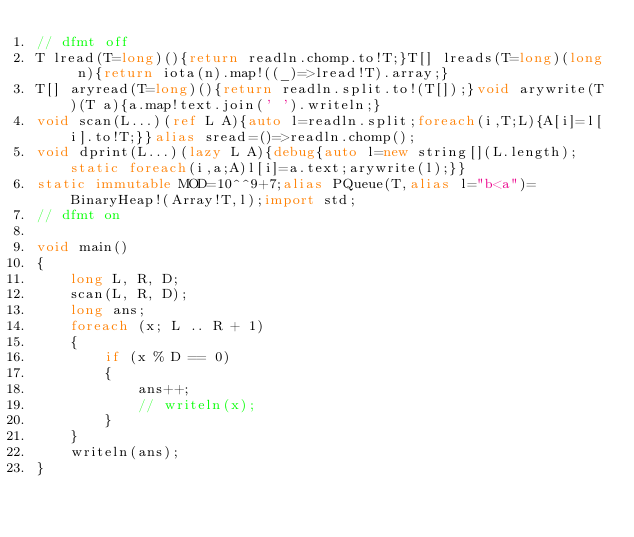Convert code to text. <code><loc_0><loc_0><loc_500><loc_500><_D_>// dfmt off
T lread(T=long)(){return readln.chomp.to!T;}T[] lreads(T=long)(long n){return iota(n).map!((_)=>lread!T).array;}
T[] aryread(T=long)(){return readln.split.to!(T[]);}void arywrite(T)(T a){a.map!text.join(' ').writeln;}
void scan(L...)(ref L A){auto l=readln.split;foreach(i,T;L){A[i]=l[i].to!T;}}alias sread=()=>readln.chomp();
void dprint(L...)(lazy L A){debug{auto l=new string[](L.length);static foreach(i,a;A)l[i]=a.text;arywrite(l);}}
static immutable MOD=10^^9+7;alias PQueue(T,alias l="b<a")=BinaryHeap!(Array!T,l);import std;
// dfmt on

void main()
{
    long L, R, D;
    scan(L, R, D);
    long ans;
    foreach (x; L .. R + 1)
    {
        if (x % D == 0)
        {
            ans++;
            // writeln(x);
        }
    }
    writeln(ans);
}
</code> 